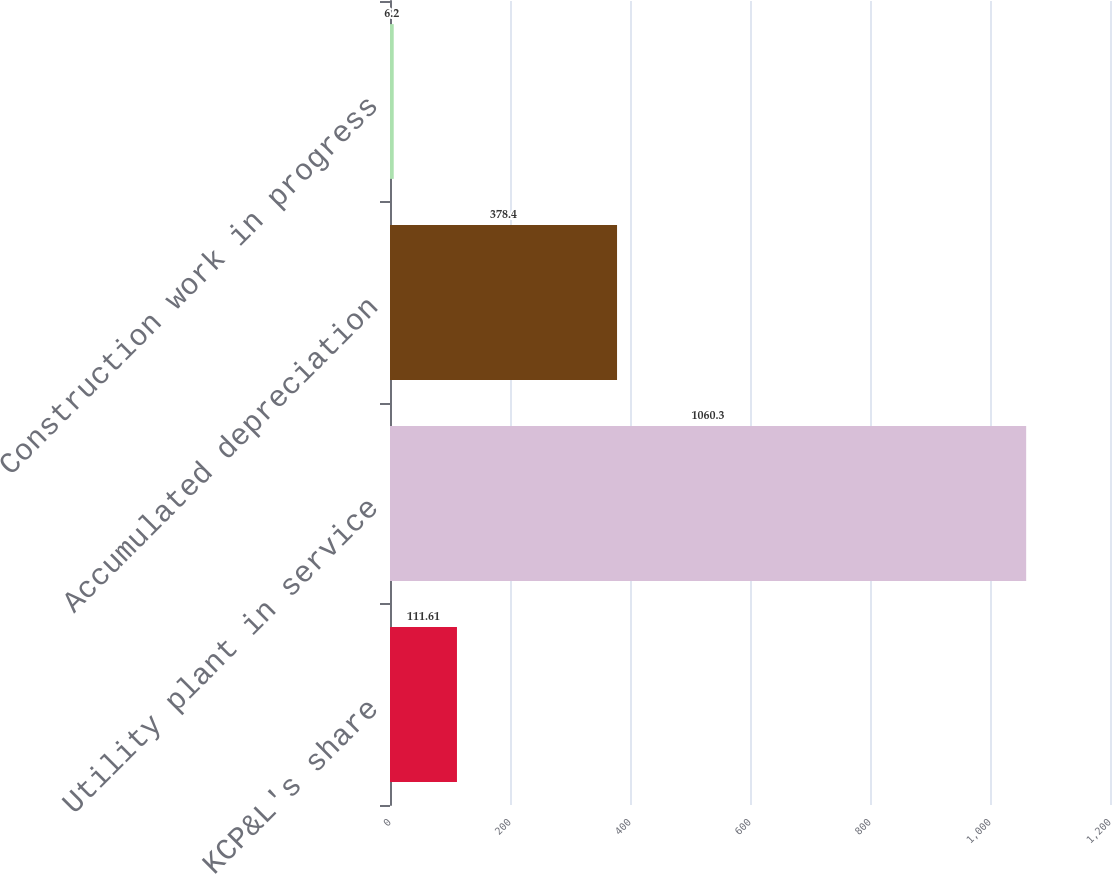<chart> <loc_0><loc_0><loc_500><loc_500><bar_chart><fcel>KCP&L's share<fcel>Utility plant in service<fcel>Accumulated depreciation<fcel>Construction work in progress<nl><fcel>111.61<fcel>1060.3<fcel>378.4<fcel>6.2<nl></chart> 